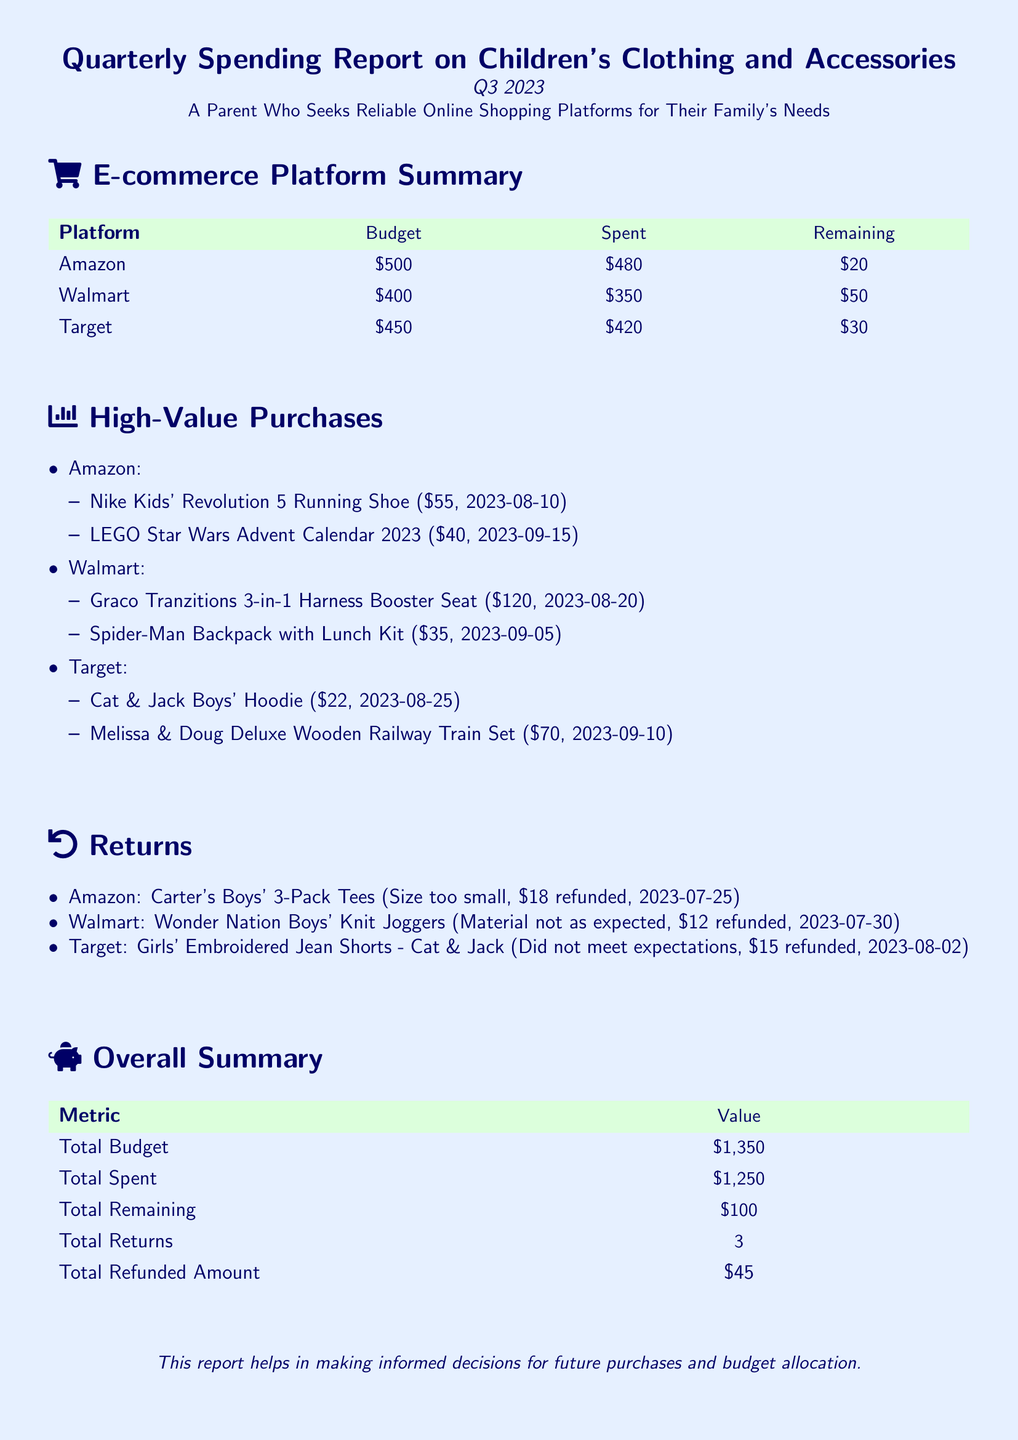What is the total budget for Q3 2023? The total budget is the sum of budgets allocated to each e-commerce platform, which is $500 + $400 + $450.
Answer: $1,350 How much was spent on Walmart? The amount spent on Walmart is directly listed in the document as part of the budget summary.
Answer: $350 What is the amount remaining from Amazon's budget? The remaining budget from Amazon is calculated by subtracting the spent amount from the allocated budget.
Answer: $20 Which platform had the highest value purchase? This question requires determining which platform's high-value purchases add up or are of notable value based on listed items.
Answer: Walmart What was the reason for the return from Amazon? The reason for the return is explicitly mentioned in the returns section as a reason for refund.
Answer: Size too small What is the total refunded amount from all platforms? The total refunded amount is the sum of all individual refunds mentioned in the returns section of the report.
Answer: $45 What was the date of the purchase for the Graco Tranzitions booster seat? The purchase date is specified alongside the item in the high-value purchases section.
Answer: 2023-08-20 How many returns were made in total? The total number of returns is explicitly listed in the overall summary of the report.
Answer: 3 What is the value of the LEGO Star Wars Advent Calendar 2023? The price of the LEGO Star Wars Advent Calendar is specifically stated under high-value purchases.
Answer: $40 